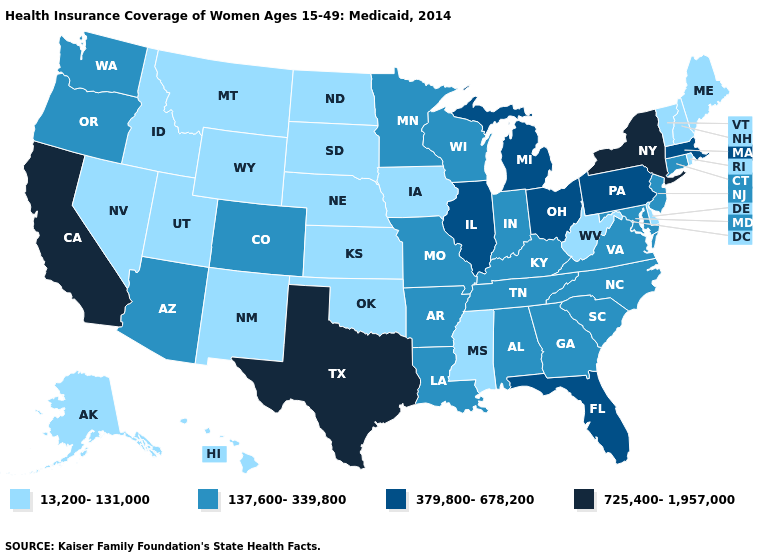What is the lowest value in the USA?
Give a very brief answer. 13,200-131,000. Among the states that border Oregon , does Washington have the highest value?
Write a very short answer. No. Does California have the highest value in the USA?
Concise answer only. Yes. Does Idaho have the lowest value in the West?
Write a very short answer. Yes. Does the map have missing data?
Be succinct. No. Does California have a lower value than Maryland?
Be succinct. No. What is the value of Missouri?
Quick response, please. 137,600-339,800. Which states have the lowest value in the South?
Write a very short answer. Delaware, Mississippi, Oklahoma, West Virginia. What is the value of Montana?
Answer briefly. 13,200-131,000. Does Missouri have the highest value in the MidWest?
Short answer required. No. What is the value of Montana?
Be succinct. 13,200-131,000. Among the states that border Oklahoma , does Texas have the highest value?
Quick response, please. Yes. Name the states that have a value in the range 13,200-131,000?
Answer briefly. Alaska, Delaware, Hawaii, Idaho, Iowa, Kansas, Maine, Mississippi, Montana, Nebraska, Nevada, New Hampshire, New Mexico, North Dakota, Oklahoma, Rhode Island, South Dakota, Utah, Vermont, West Virginia, Wyoming. Which states have the lowest value in the USA?
Keep it brief. Alaska, Delaware, Hawaii, Idaho, Iowa, Kansas, Maine, Mississippi, Montana, Nebraska, Nevada, New Hampshire, New Mexico, North Dakota, Oklahoma, Rhode Island, South Dakota, Utah, Vermont, West Virginia, Wyoming. Name the states that have a value in the range 13,200-131,000?
Write a very short answer. Alaska, Delaware, Hawaii, Idaho, Iowa, Kansas, Maine, Mississippi, Montana, Nebraska, Nevada, New Hampshire, New Mexico, North Dakota, Oklahoma, Rhode Island, South Dakota, Utah, Vermont, West Virginia, Wyoming. 